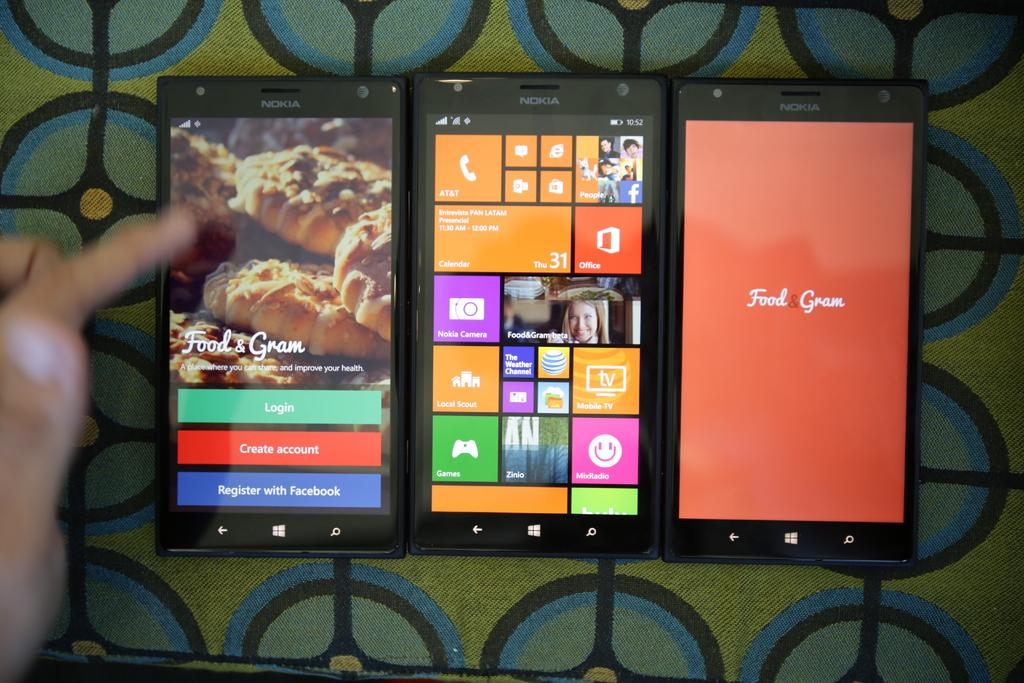What is the main subject in the center of the image? There are three mobiles in the center of the image. Where are the mobiles located? The mobiles are on a surface. Can you describe anything else in the image? There is a person's hand on the left side of the image. What decision does the father make in the image? There is no father or decision-making process depicted in the image. What type of produce is being harvested in the image? There is no produce or harvesting activity shown in the image. 